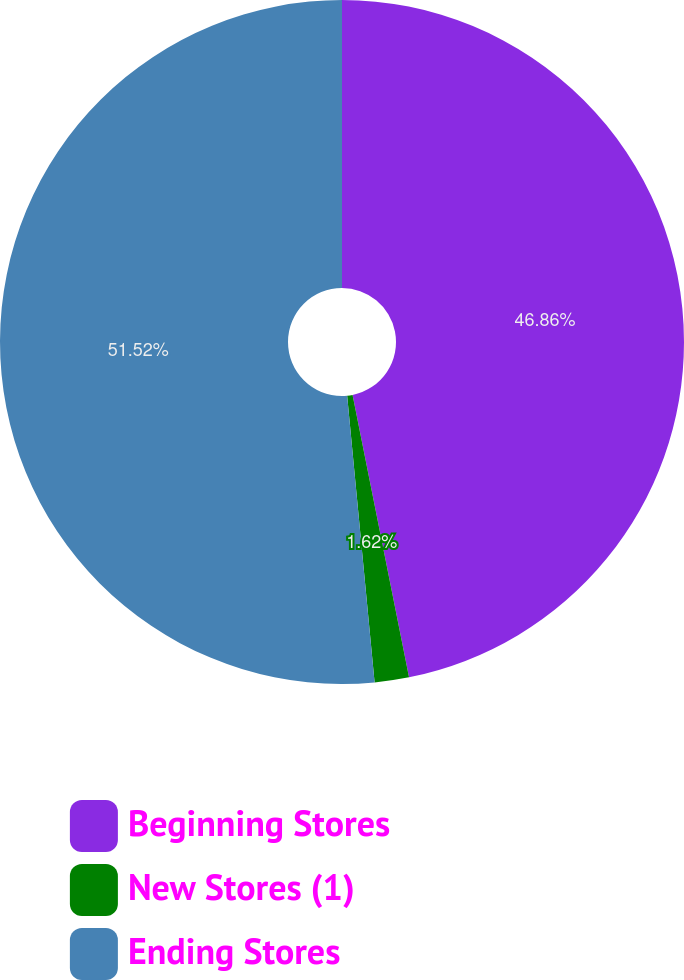Convert chart to OTSL. <chart><loc_0><loc_0><loc_500><loc_500><pie_chart><fcel>Beginning Stores<fcel>New Stores (1)<fcel>Ending Stores<nl><fcel>46.86%<fcel>1.62%<fcel>51.52%<nl></chart> 